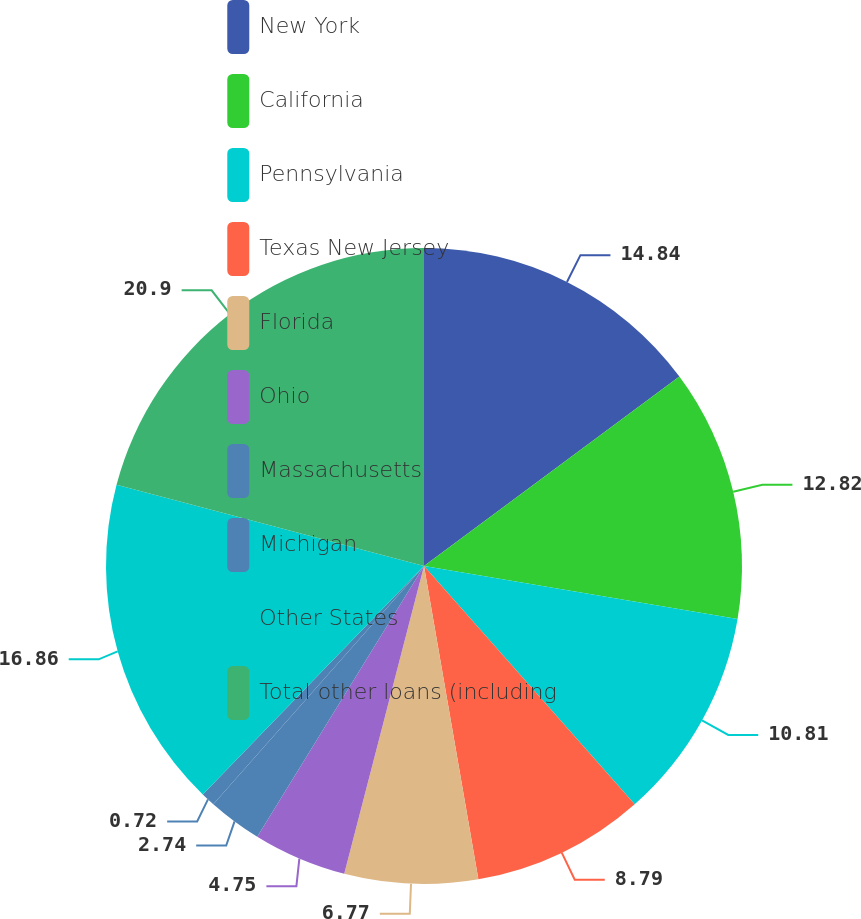Convert chart to OTSL. <chart><loc_0><loc_0><loc_500><loc_500><pie_chart><fcel>New York<fcel>California<fcel>Pennsylvania<fcel>Texas New Jersey<fcel>Florida<fcel>Ohio<fcel>Massachusetts<fcel>Michigan<fcel>Other States<fcel>Total other loans (including<nl><fcel>14.84%<fcel>12.82%<fcel>10.81%<fcel>8.79%<fcel>6.77%<fcel>4.75%<fcel>2.74%<fcel>0.72%<fcel>16.86%<fcel>20.89%<nl></chart> 